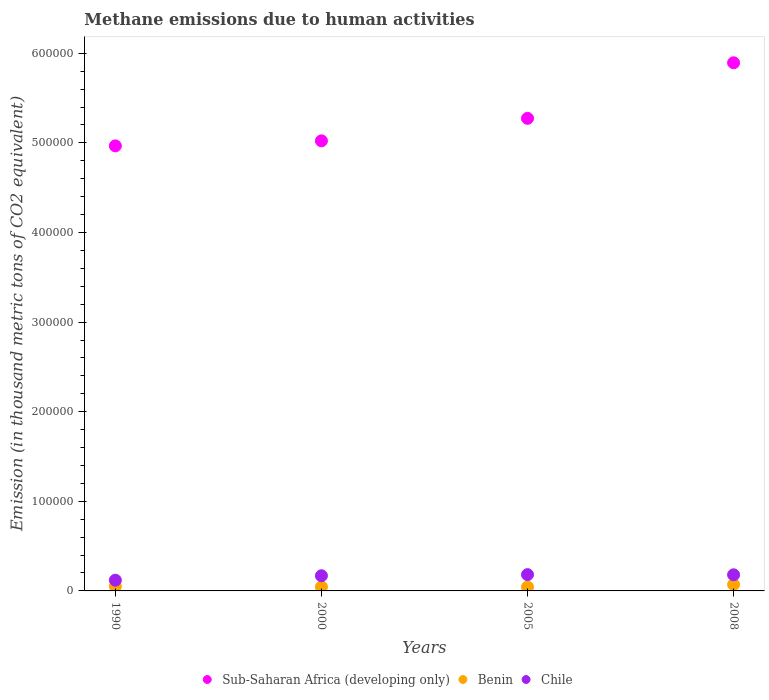How many different coloured dotlines are there?
Offer a terse response. 3. Is the number of dotlines equal to the number of legend labels?
Your response must be concise. Yes. What is the amount of methane emitted in Benin in 1990?
Ensure brevity in your answer.  5119.5. Across all years, what is the maximum amount of methane emitted in Chile?
Ensure brevity in your answer.  1.82e+04. Across all years, what is the minimum amount of methane emitted in Benin?
Provide a short and direct response. 4377.3. In which year was the amount of methane emitted in Chile maximum?
Provide a short and direct response. 2005. In which year was the amount of methane emitted in Sub-Saharan Africa (developing only) minimum?
Make the answer very short. 1990. What is the total amount of methane emitted in Sub-Saharan Africa (developing only) in the graph?
Your response must be concise. 2.12e+06. What is the difference between the amount of methane emitted in Benin in 2000 and that in 2005?
Make the answer very short. 126.5. What is the difference between the amount of methane emitted in Benin in 1990 and the amount of methane emitted in Chile in 2000?
Make the answer very short. -1.18e+04. What is the average amount of methane emitted in Chile per year?
Offer a terse response. 1.63e+04. In the year 2008, what is the difference between the amount of methane emitted in Sub-Saharan Africa (developing only) and amount of methane emitted in Chile?
Provide a short and direct response. 5.71e+05. What is the ratio of the amount of methane emitted in Chile in 1990 to that in 2005?
Provide a succinct answer. 0.66. Is the amount of methane emitted in Sub-Saharan Africa (developing only) in 2005 less than that in 2008?
Offer a very short reply. Yes. What is the difference between the highest and the second highest amount of methane emitted in Benin?
Make the answer very short. 1967.1. What is the difference between the highest and the lowest amount of methane emitted in Benin?
Make the answer very short. 2709.3. Is the sum of the amount of methane emitted in Sub-Saharan Africa (developing only) in 2005 and 2008 greater than the maximum amount of methane emitted in Chile across all years?
Provide a succinct answer. Yes. Is it the case that in every year, the sum of the amount of methane emitted in Benin and amount of methane emitted in Sub-Saharan Africa (developing only)  is greater than the amount of methane emitted in Chile?
Ensure brevity in your answer.  Yes. Does the amount of methane emitted in Sub-Saharan Africa (developing only) monotonically increase over the years?
Offer a terse response. Yes. Is the amount of methane emitted in Chile strictly greater than the amount of methane emitted in Sub-Saharan Africa (developing only) over the years?
Provide a short and direct response. No. Is the amount of methane emitted in Chile strictly less than the amount of methane emitted in Sub-Saharan Africa (developing only) over the years?
Give a very brief answer. Yes. What is the difference between two consecutive major ticks on the Y-axis?
Keep it short and to the point. 1.00e+05. Does the graph contain grids?
Provide a short and direct response. No. How are the legend labels stacked?
Provide a succinct answer. Horizontal. What is the title of the graph?
Offer a terse response. Methane emissions due to human activities. Does "Turkey" appear as one of the legend labels in the graph?
Your response must be concise. No. What is the label or title of the X-axis?
Keep it short and to the point. Years. What is the label or title of the Y-axis?
Give a very brief answer. Emission (in thousand metric tons of CO2 equivalent). What is the Emission (in thousand metric tons of CO2 equivalent) in Sub-Saharan Africa (developing only) in 1990?
Your answer should be compact. 4.97e+05. What is the Emission (in thousand metric tons of CO2 equivalent) in Benin in 1990?
Ensure brevity in your answer.  5119.5. What is the Emission (in thousand metric tons of CO2 equivalent) of Chile in 1990?
Offer a very short reply. 1.20e+04. What is the Emission (in thousand metric tons of CO2 equivalent) of Sub-Saharan Africa (developing only) in 2000?
Offer a very short reply. 5.02e+05. What is the Emission (in thousand metric tons of CO2 equivalent) of Benin in 2000?
Provide a short and direct response. 4503.8. What is the Emission (in thousand metric tons of CO2 equivalent) in Chile in 2000?
Ensure brevity in your answer.  1.69e+04. What is the Emission (in thousand metric tons of CO2 equivalent) in Sub-Saharan Africa (developing only) in 2005?
Make the answer very short. 5.27e+05. What is the Emission (in thousand metric tons of CO2 equivalent) in Benin in 2005?
Ensure brevity in your answer.  4377.3. What is the Emission (in thousand metric tons of CO2 equivalent) of Chile in 2005?
Your answer should be very brief. 1.82e+04. What is the Emission (in thousand metric tons of CO2 equivalent) of Sub-Saharan Africa (developing only) in 2008?
Your answer should be very brief. 5.89e+05. What is the Emission (in thousand metric tons of CO2 equivalent) of Benin in 2008?
Ensure brevity in your answer.  7086.6. What is the Emission (in thousand metric tons of CO2 equivalent) in Chile in 2008?
Keep it short and to the point. 1.80e+04. Across all years, what is the maximum Emission (in thousand metric tons of CO2 equivalent) in Sub-Saharan Africa (developing only)?
Ensure brevity in your answer.  5.89e+05. Across all years, what is the maximum Emission (in thousand metric tons of CO2 equivalent) in Benin?
Offer a terse response. 7086.6. Across all years, what is the maximum Emission (in thousand metric tons of CO2 equivalent) of Chile?
Ensure brevity in your answer.  1.82e+04. Across all years, what is the minimum Emission (in thousand metric tons of CO2 equivalent) of Sub-Saharan Africa (developing only)?
Make the answer very short. 4.97e+05. Across all years, what is the minimum Emission (in thousand metric tons of CO2 equivalent) in Benin?
Provide a succinct answer. 4377.3. Across all years, what is the minimum Emission (in thousand metric tons of CO2 equivalent) in Chile?
Offer a very short reply. 1.20e+04. What is the total Emission (in thousand metric tons of CO2 equivalent) in Sub-Saharan Africa (developing only) in the graph?
Provide a succinct answer. 2.12e+06. What is the total Emission (in thousand metric tons of CO2 equivalent) of Benin in the graph?
Your response must be concise. 2.11e+04. What is the total Emission (in thousand metric tons of CO2 equivalent) in Chile in the graph?
Offer a terse response. 6.51e+04. What is the difference between the Emission (in thousand metric tons of CO2 equivalent) in Sub-Saharan Africa (developing only) in 1990 and that in 2000?
Provide a succinct answer. -5608.2. What is the difference between the Emission (in thousand metric tons of CO2 equivalent) of Benin in 1990 and that in 2000?
Your response must be concise. 615.7. What is the difference between the Emission (in thousand metric tons of CO2 equivalent) in Chile in 1990 and that in 2000?
Offer a terse response. -4945.1. What is the difference between the Emission (in thousand metric tons of CO2 equivalent) of Sub-Saharan Africa (developing only) in 1990 and that in 2005?
Make the answer very short. -3.07e+04. What is the difference between the Emission (in thousand metric tons of CO2 equivalent) in Benin in 1990 and that in 2005?
Your answer should be compact. 742.2. What is the difference between the Emission (in thousand metric tons of CO2 equivalent) of Chile in 1990 and that in 2005?
Your answer should be compact. -6211.6. What is the difference between the Emission (in thousand metric tons of CO2 equivalent) of Sub-Saharan Africa (developing only) in 1990 and that in 2008?
Keep it short and to the point. -9.27e+04. What is the difference between the Emission (in thousand metric tons of CO2 equivalent) in Benin in 1990 and that in 2008?
Your answer should be compact. -1967.1. What is the difference between the Emission (in thousand metric tons of CO2 equivalent) of Chile in 1990 and that in 2008?
Offer a terse response. -6011.3. What is the difference between the Emission (in thousand metric tons of CO2 equivalent) in Sub-Saharan Africa (developing only) in 2000 and that in 2005?
Ensure brevity in your answer.  -2.51e+04. What is the difference between the Emission (in thousand metric tons of CO2 equivalent) in Benin in 2000 and that in 2005?
Make the answer very short. 126.5. What is the difference between the Emission (in thousand metric tons of CO2 equivalent) in Chile in 2000 and that in 2005?
Offer a very short reply. -1266.5. What is the difference between the Emission (in thousand metric tons of CO2 equivalent) of Sub-Saharan Africa (developing only) in 2000 and that in 2008?
Your answer should be compact. -8.71e+04. What is the difference between the Emission (in thousand metric tons of CO2 equivalent) in Benin in 2000 and that in 2008?
Provide a succinct answer. -2582.8. What is the difference between the Emission (in thousand metric tons of CO2 equivalent) in Chile in 2000 and that in 2008?
Keep it short and to the point. -1066.2. What is the difference between the Emission (in thousand metric tons of CO2 equivalent) in Sub-Saharan Africa (developing only) in 2005 and that in 2008?
Your response must be concise. -6.20e+04. What is the difference between the Emission (in thousand metric tons of CO2 equivalent) of Benin in 2005 and that in 2008?
Your answer should be compact. -2709.3. What is the difference between the Emission (in thousand metric tons of CO2 equivalent) of Chile in 2005 and that in 2008?
Make the answer very short. 200.3. What is the difference between the Emission (in thousand metric tons of CO2 equivalent) in Sub-Saharan Africa (developing only) in 1990 and the Emission (in thousand metric tons of CO2 equivalent) in Benin in 2000?
Give a very brief answer. 4.92e+05. What is the difference between the Emission (in thousand metric tons of CO2 equivalent) in Sub-Saharan Africa (developing only) in 1990 and the Emission (in thousand metric tons of CO2 equivalent) in Chile in 2000?
Your response must be concise. 4.80e+05. What is the difference between the Emission (in thousand metric tons of CO2 equivalent) in Benin in 1990 and the Emission (in thousand metric tons of CO2 equivalent) in Chile in 2000?
Provide a succinct answer. -1.18e+04. What is the difference between the Emission (in thousand metric tons of CO2 equivalent) of Sub-Saharan Africa (developing only) in 1990 and the Emission (in thousand metric tons of CO2 equivalent) of Benin in 2005?
Offer a very short reply. 4.92e+05. What is the difference between the Emission (in thousand metric tons of CO2 equivalent) of Sub-Saharan Africa (developing only) in 1990 and the Emission (in thousand metric tons of CO2 equivalent) of Chile in 2005?
Provide a short and direct response. 4.78e+05. What is the difference between the Emission (in thousand metric tons of CO2 equivalent) of Benin in 1990 and the Emission (in thousand metric tons of CO2 equivalent) of Chile in 2005?
Your answer should be compact. -1.31e+04. What is the difference between the Emission (in thousand metric tons of CO2 equivalent) in Sub-Saharan Africa (developing only) in 1990 and the Emission (in thousand metric tons of CO2 equivalent) in Benin in 2008?
Provide a succinct answer. 4.90e+05. What is the difference between the Emission (in thousand metric tons of CO2 equivalent) in Sub-Saharan Africa (developing only) in 1990 and the Emission (in thousand metric tons of CO2 equivalent) in Chile in 2008?
Give a very brief answer. 4.79e+05. What is the difference between the Emission (in thousand metric tons of CO2 equivalent) of Benin in 1990 and the Emission (in thousand metric tons of CO2 equivalent) of Chile in 2008?
Give a very brief answer. -1.29e+04. What is the difference between the Emission (in thousand metric tons of CO2 equivalent) of Sub-Saharan Africa (developing only) in 2000 and the Emission (in thousand metric tons of CO2 equivalent) of Benin in 2005?
Your response must be concise. 4.98e+05. What is the difference between the Emission (in thousand metric tons of CO2 equivalent) in Sub-Saharan Africa (developing only) in 2000 and the Emission (in thousand metric tons of CO2 equivalent) in Chile in 2005?
Your answer should be very brief. 4.84e+05. What is the difference between the Emission (in thousand metric tons of CO2 equivalent) of Benin in 2000 and the Emission (in thousand metric tons of CO2 equivalent) of Chile in 2005?
Offer a very short reply. -1.37e+04. What is the difference between the Emission (in thousand metric tons of CO2 equivalent) in Sub-Saharan Africa (developing only) in 2000 and the Emission (in thousand metric tons of CO2 equivalent) in Benin in 2008?
Your answer should be compact. 4.95e+05. What is the difference between the Emission (in thousand metric tons of CO2 equivalent) in Sub-Saharan Africa (developing only) in 2000 and the Emission (in thousand metric tons of CO2 equivalent) in Chile in 2008?
Your answer should be compact. 4.84e+05. What is the difference between the Emission (in thousand metric tons of CO2 equivalent) of Benin in 2000 and the Emission (in thousand metric tons of CO2 equivalent) of Chile in 2008?
Provide a succinct answer. -1.35e+04. What is the difference between the Emission (in thousand metric tons of CO2 equivalent) of Sub-Saharan Africa (developing only) in 2005 and the Emission (in thousand metric tons of CO2 equivalent) of Benin in 2008?
Keep it short and to the point. 5.20e+05. What is the difference between the Emission (in thousand metric tons of CO2 equivalent) of Sub-Saharan Africa (developing only) in 2005 and the Emission (in thousand metric tons of CO2 equivalent) of Chile in 2008?
Give a very brief answer. 5.09e+05. What is the difference between the Emission (in thousand metric tons of CO2 equivalent) of Benin in 2005 and the Emission (in thousand metric tons of CO2 equivalent) of Chile in 2008?
Offer a very short reply. -1.36e+04. What is the average Emission (in thousand metric tons of CO2 equivalent) in Sub-Saharan Africa (developing only) per year?
Offer a terse response. 5.29e+05. What is the average Emission (in thousand metric tons of CO2 equivalent) in Benin per year?
Your answer should be very brief. 5271.8. What is the average Emission (in thousand metric tons of CO2 equivalent) in Chile per year?
Provide a short and direct response. 1.63e+04. In the year 1990, what is the difference between the Emission (in thousand metric tons of CO2 equivalent) of Sub-Saharan Africa (developing only) and Emission (in thousand metric tons of CO2 equivalent) of Benin?
Provide a short and direct response. 4.92e+05. In the year 1990, what is the difference between the Emission (in thousand metric tons of CO2 equivalent) in Sub-Saharan Africa (developing only) and Emission (in thousand metric tons of CO2 equivalent) in Chile?
Your answer should be compact. 4.85e+05. In the year 1990, what is the difference between the Emission (in thousand metric tons of CO2 equivalent) in Benin and Emission (in thousand metric tons of CO2 equivalent) in Chile?
Give a very brief answer. -6858.6. In the year 2000, what is the difference between the Emission (in thousand metric tons of CO2 equivalent) of Sub-Saharan Africa (developing only) and Emission (in thousand metric tons of CO2 equivalent) of Benin?
Your answer should be very brief. 4.98e+05. In the year 2000, what is the difference between the Emission (in thousand metric tons of CO2 equivalent) of Sub-Saharan Africa (developing only) and Emission (in thousand metric tons of CO2 equivalent) of Chile?
Your answer should be very brief. 4.85e+05. In the year 2000, what is the difference between the Emission (in thousand metric tons of CO2 equivalent) in Benin and Emission (in thousand metric tons of CO2 equivalent) in Chile?
Keep it short and to the point. -1.24e+04. In the year 2005, what is the difference between the Emission (in thousand metric tons of CO2 equivalent) of Sub-Saharan Africa (developing only) and Emission (in thousand metric tons of CO2 equivalent) of Benin?
Your answer should be compact. 5.23e+05. In the year 2005, what is the difference between the Emission (in thousand metric tons of CO2 equivalent) in Sub-Saharan Africa (developing only) and Emission (in thousand metric tons of CO2 equivalent) in Chile?
Provide a succinct answer. 5.09e+05. In the year 2005, what is the difference between the Emission (in thousand metric tons of CO2 equivalent) in Benin and Emission (in thousand metric tons of CO2 equivalent) in Chile?
Your answer should be compact. -1.38e+04. In the year 2008, what is the difference between the Emission (in thousand metric tons of CO2 equivalent) of Sub-Saharan Africa (developing only) and Emission (in thousand metric tons of CO2 equivalent) of Benin?
Your answer should be very brief. 5.82e+05. In the year 2008, what is the difference between the Emission (in thousand metric tons of CO2 equivalent) of Sub-Saharan Africa (developing only) and Emission (in thousand metric tons of CO2 equivalent) of Chile?
Provide a short and direct response. 5.71e+05. In the year 2008, what is the difference between the Emission (in thousand metric tons of CO2 equivalent) of Benin and Emission (in thousand metric tons of CO2 equivalent) of Chile?
Offer a very short reply. -1.09e+04. What is the ratio of the Emission (in thousand metric tons of CO2 equivalent) of Benin in 1990 to that in 2000?
Your response must be concise. 1.14. What is the ratio of the Emission (in thousand metric tons of CO2 equivalent) of Chile in 1990 to that in 2000?
Make the answer very short. 0.71. What is the ratio of the Emission (in thousand metric tons of CO2 equivalent) of Sub-Saharan Africa (developing only) in 1990 to that in 2005?
Offer a terse response. 0.94. What is the ratio of the Emission (in thousand metric tons of CO2 equivalent) in Benin in 1990 to that in 2005?
Your answer should be very brief. 1.17. What is the ratio of the Emission (in thousand metric tons of CO2 equivalent) in Chile in 1990 to that in 2005?
Provide a succinct answer. 0.66. What is the ratio of the Emission (in thousand metric tons of CO2 equivalent) of Sub-Saharan Africa (developing only) in 1990 to that in 2008?
Keep it short and to the point. 0.84. What is the ratio of the Emission (in thousand metric tons of CO2 equivalent) in Benin in 1990 to that in 2008?
Your answer should be very brief. 0.72. What is the ratio of the Emission (in thousand metric tons of CO2 equivalent) of Chile in 1990 to that in 2008?
Offer a very short reply. 0.67. What is the ratio of the Emission (in thousand metric tons of CO2 equivalent) in Benin in 2000 to that in 2005?
Keep it short and to the point. 1.03. What is the ratio of the Emission (in thousand metric tons of CO2 equivalent) of Chile in 2000 to that in 2005?
Offer a terse response. 0.93. What is the ratio of the Emission (in thousand metric tons of CO2 equivalent) of Sub-Saharan Africa (developing only) in 2000 to that in 2008?
Ensure brevity in your answer.  0.85. What is the ratio of the Emission (in thousand metric tons of CO2 equivalent) of Benin in 2000 to that in 2008?
Your answer should be compact. 0.64. What is the ratio of the Emission (in thousand metric tons of CO2 equivalent) in Chile in 2000 to that in 2008?
Make the answer very short. 0.94. What is the ratio of the Emission (in thousand metric tons of CO2 equivalent) in Sub-Saharan Africa (developing only) in 2005 to that in 2008?
Your answer should be compact. 0.89. What is the ratio of the Emission (in thousand metric tons of CO2 equivalent) in Benin in 2005 to that in 2008?
Your answer should be compact. 0.62. What is the ratio of the Emission (in thousand metric tons of CO2 equivalent) in Chile in 2005 to that in 2008?
Ensure brevity in your answer.  1.01. What is the difference between the highest and the second highest Emission (in thousand metric tons of CO2 equivalent) in Sub-Saharan Africa (developing only)?
Your answer should be compact. 6.20e+04. What is the difference between the highest and the second highest Emission (in thousand metric tons of CO2 equivalent) of Benin?
Your answer should be compact. 1967.1. What is the difference between the highest and the second highest Emission (in thousand metric tons of CO2 equivalent) in Chile?
Your response must be concise. 200.3. What is the difference between the highest and the lowest Emission (in thousand metric tons of CO2 equivalent) of Sub-Saharan Africa (developing only)?
Your answer should be very brief. 9.27e+04. What is the difference between the highest and the lowest Emission (in thousand metric tons of CO2 equivalent) in Benin?
Ensure brevity in your answer.  2709.3. What is the difference between the highest and the lowest Emission (in thousand metric tons of CO2 equivalent) in Chile?
Your answer should be compact. 6211.6. 